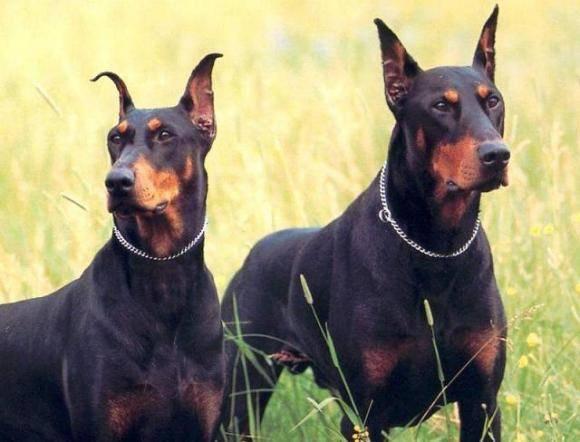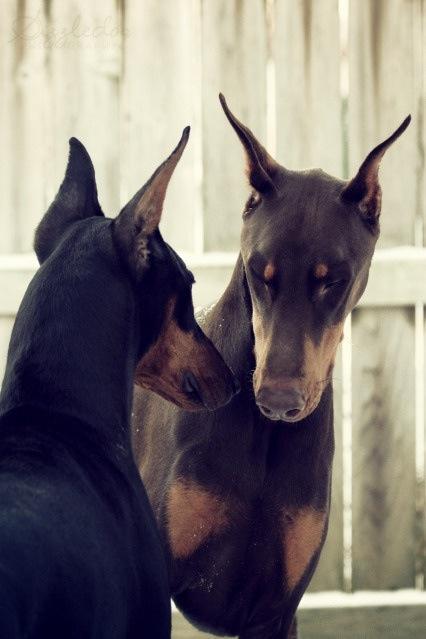The first image is the image on the left, the second image is the image on the right. Examine the images to the left and right. Is the description "A dog in one of the images is solid white, and one dog has a very visible collar." accurate? Answer yes or no. No. 